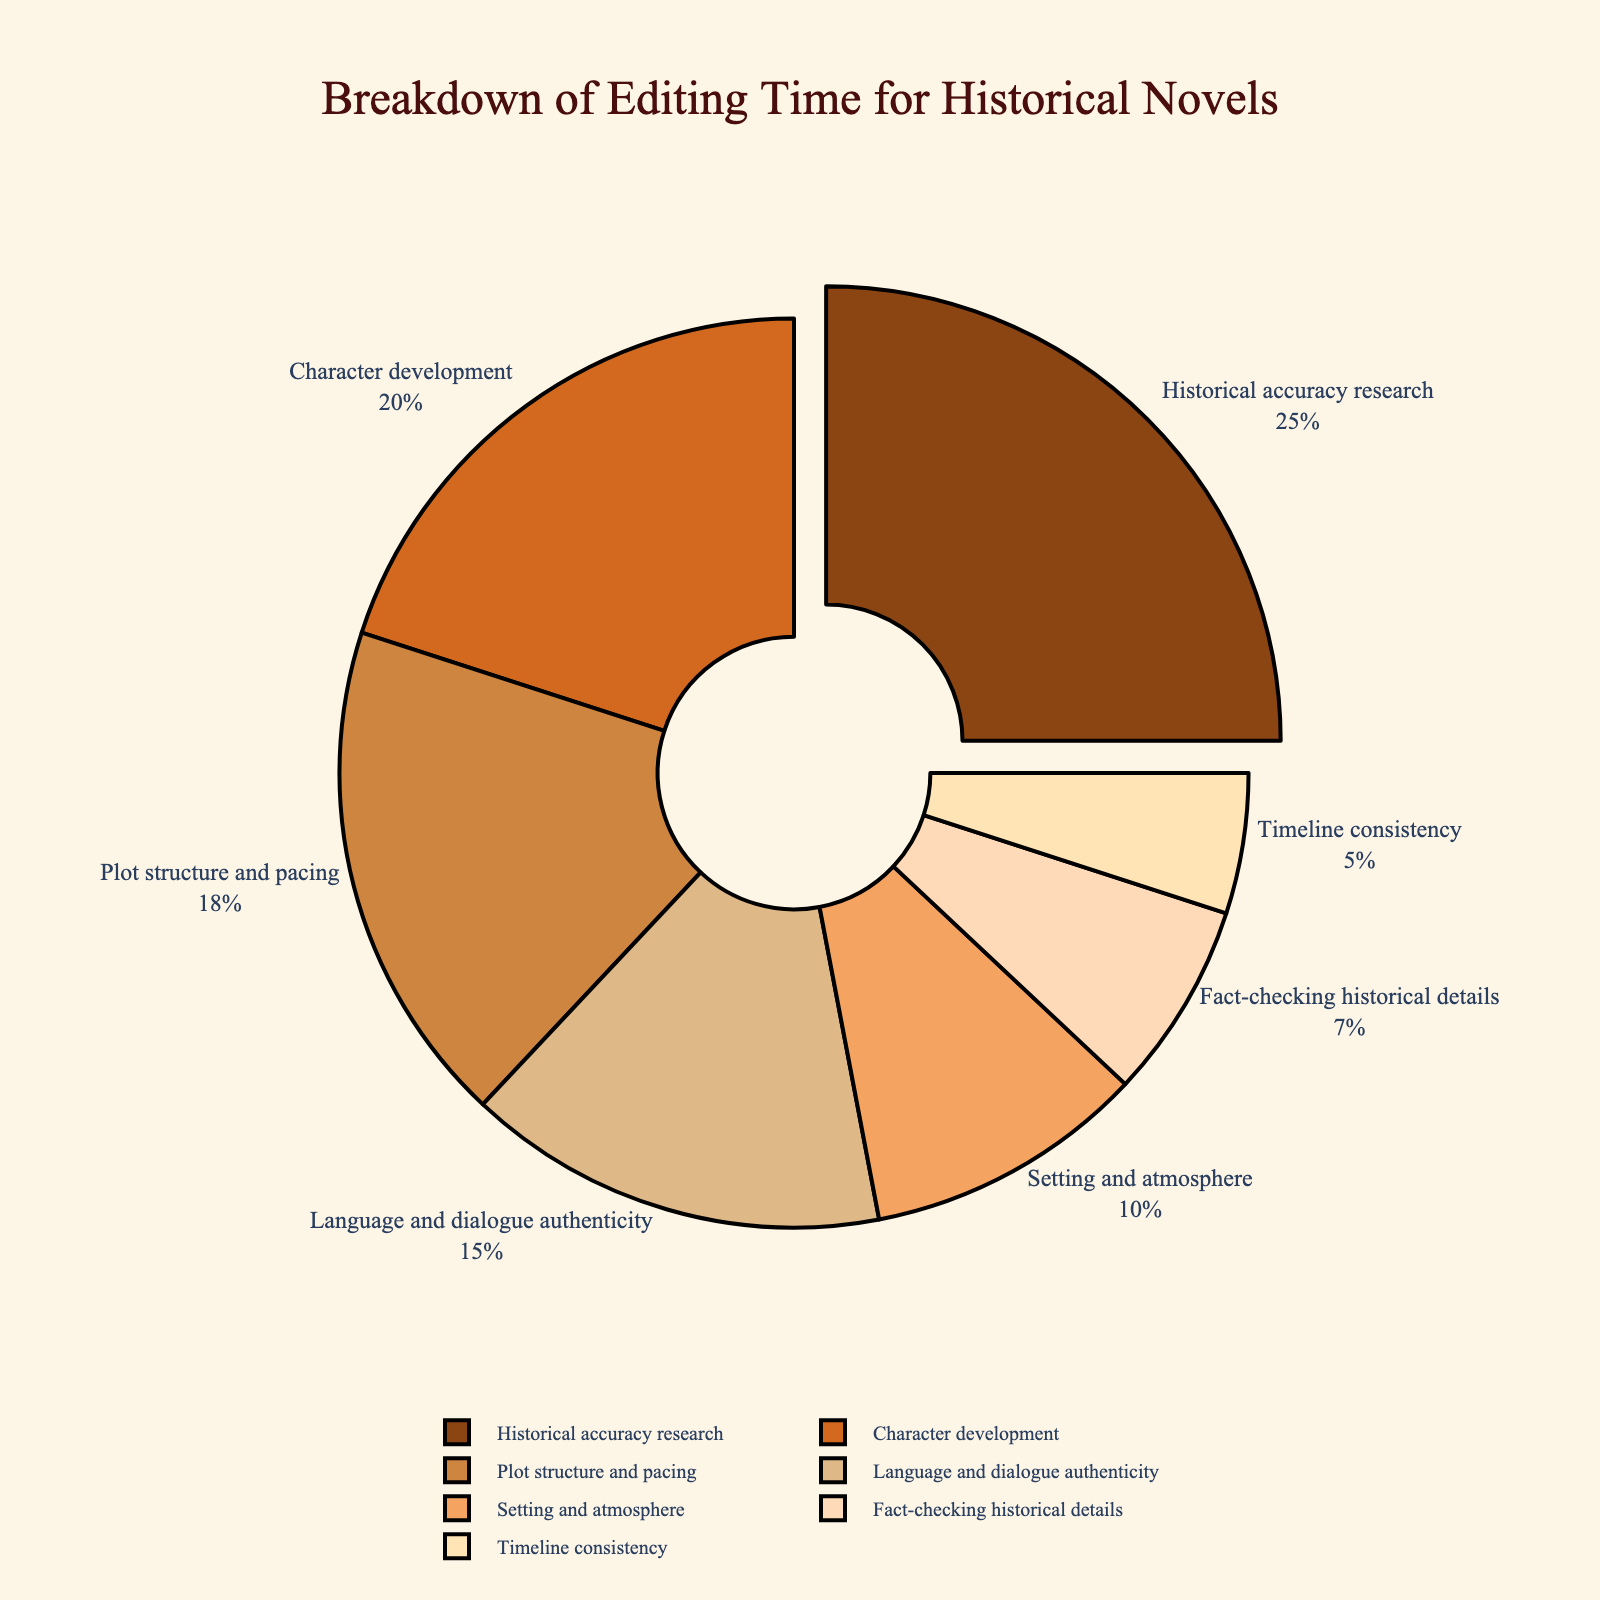What aspect of editing takes up the largest percentage of time? The figure shows different aspects of editing with their corresponding percentages. The largest percentage segment represents the aspect that occupies the most time, which is historical accuracy research at 25%.
Answer: Historical accuracy research Which two aspects combined take up the same or more percentage of time than historical accuracy research? To find aspects that combined take 25% or more, check for pairs whose percentages sum to at least 25%. For example, character development (20%) and fact-checking historical details (7%) together make 27%, which is more than 25%.
Answer: Character development and fact-checking historical details What is the combined percentage of time spent on language and dialogue authenticity and setting and atmosphere? Sum the percentages for language and dialogue authenticity (15%) and setting and atmosphere (10%). 15% + 10% = 25%.
Answer: 25% Which aspect requires more time: plot structure and pacing or timeline consistency? Compare the percentages of plot structure and pacing (18%) and timeline consistency (5%). Plot structure and pacing takes more time.
Answer: Plot structure and pacing What is the total percentage of time spent on character development, plot structure and pacing, and setting and atmosphere? Sum the percentages for character development (20%), plot structure and pacing (18%), and setting and atmosphere (10%). 20% + 18% + 10% = 48%.
Answer: 48% What is the color associated with historical accuracy research in the pie chart? The pie chart uses specific colors for each aspect, and historical accuracy research is typically highlighted by being pulled out slightly. The color associated with it is likely the first in the color series, which appears to be brown.
Answer: Brown How much more percentage of time is devoted to language and dialogue authenticity than to timeline consistency? Subtract the percentage of timeline consistency (5%) from the percentage of language and dialogue authenticity (15%). 15% - 5% = 10%.
Answer: 10% What percentage of time is spent on both historical accuracy research and fact-checking historical details combined? Sum the percentages for historical accuracy research (25%) and fact-checking historical details (7%). 25% + 7% = 32%.
Answer: 32% Which aspect takes up the least amount of editing time? Among all the listed aspects, the one with the lowest percentage is timeline consistency at 5%.
Answer: Timeline consistency How does the percentage of setting and atmosphere compare with that of language and dialogue authenticity? Compare the percentages for setting and atmosphere (10%) and language and dialogue authenticity (15%). Language and dialogue authenticity is higher.
Answer: Language and dialogue authenticity 